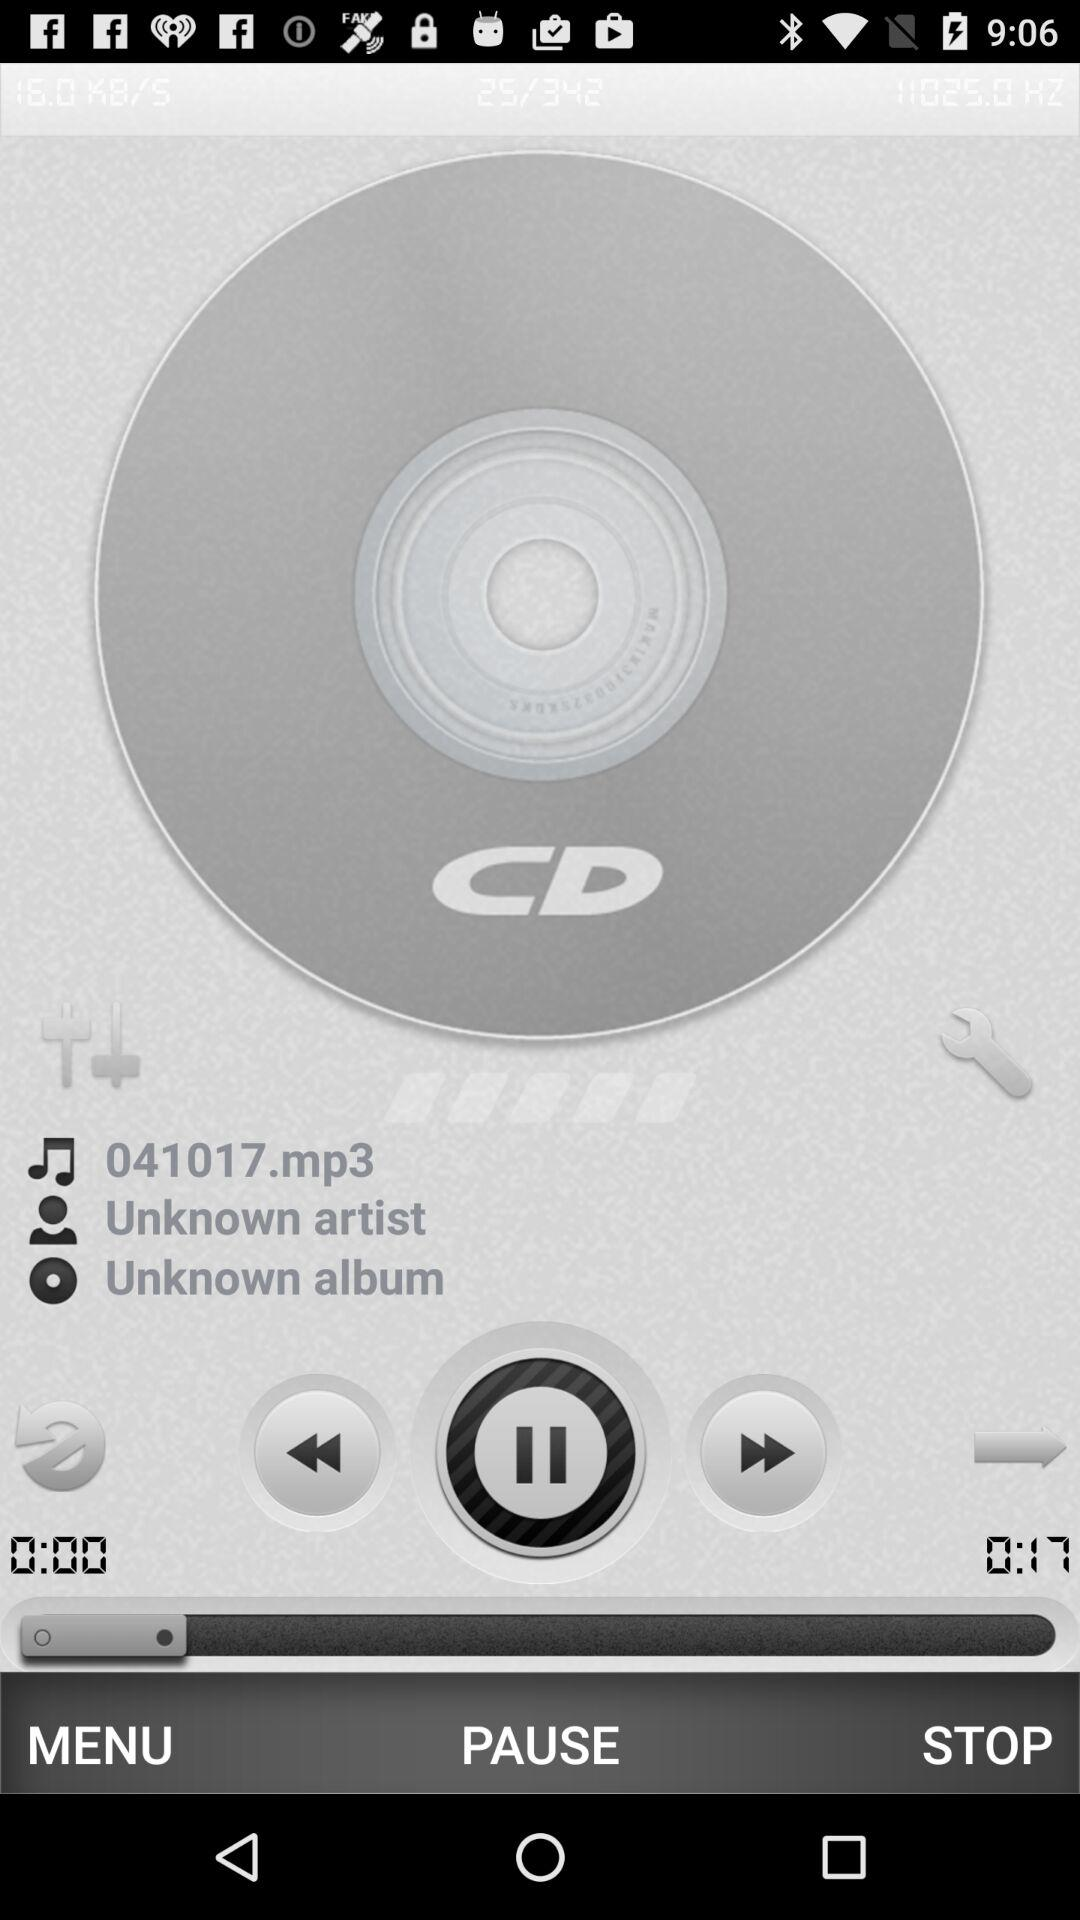Which album does the "041017.mp3" audio belong to? The "041017.mp3" audio belongs to the "Unknown" album. 